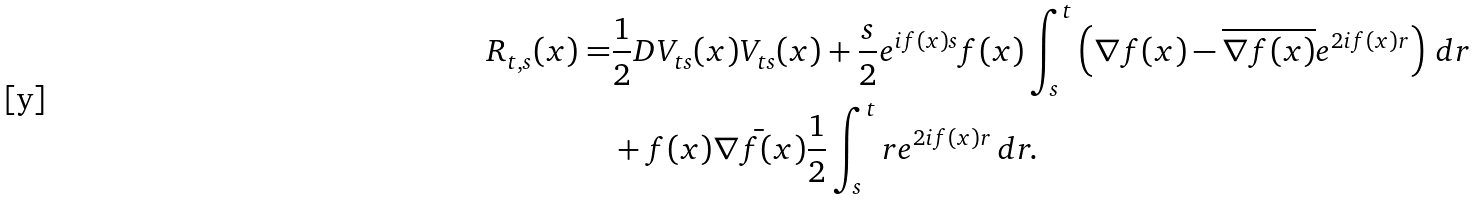<formula> <loc_0><loc_0><loc_500><loc_500>R _ { t , s } ( x ) = & \frac { 1 } { 2 } D V _ { t s } ( x ) V _ { t s } ( x ) + \frac { s } { 2 } e ^ { i f ( x ) s } f ( x ) \int _ { s } ^ { t } \left ( \nabla f ( x ) - \overline { \nabla f ( x ) } e ^ { 2 i f ( x ) r } \right ) \, d r \\ & + f ( x ) \bar { \nabla f ( x ) } \frac { 1 } { 2 } \int _ { s } ^ { t } r e ^ { 2 i f ( x ) r } \, d r .</formula> 